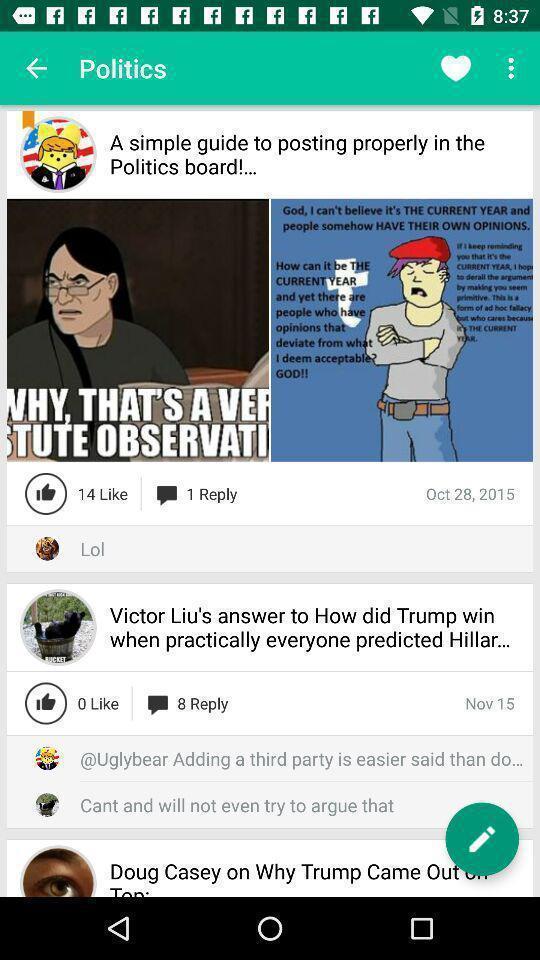Provide a description of this screenshot. Various political feed displayed. 